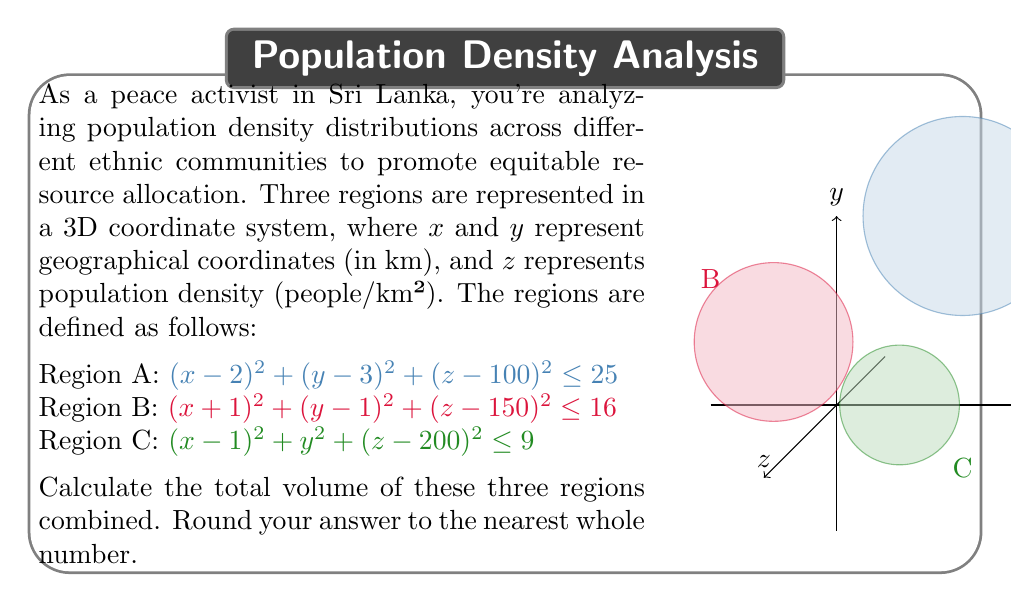Provide a solution to this math problem. Let's approach this step-by-step:

1) The given equations represent spheres in 3D space. The general equation for a sphere is $(x-h)^2 + (y-k)^2 + (z-l)^2 = r^2$, where $(h,k,l)$ is the center and $r$ is the radius.

2) For Region A:
   Center: (2, 3, 100)
   Radius: $\sqrt{25} = 5$

3) For Region B:
   Center: (-1, 1, 150)
   Radius: $\sqrt{16} = 4$

4) For Region C:
   Center: (1, 0, 200)
   Radius: $\sqrt{9} = 3$

5) The volume of a sphere is given by the formula $V = \frac{4}{3}\pi r^3$

6) Let's calculate the volume for each region:

   Region A: $V_A = \frac{4}{3}\pi 5^3 = \frac{500}{3}\pi$
   Region B: $V_B = \frac{4}{3}\pi 4^3 = \frac{256}{3}\pi$
   Region C: $V_C = \frac{4}{3}\pi 3^3 = 36\pi$

7) The total volume is the sum of these three volumes:

   $V_{total} = V_A + V_B + V_C = (\frac{500}{3} + \frac{256}{3} + 36)\pi$
              $= (\frac{500 + 256 + 108}{3})\pi$
              $= \frac{864}{3}\pi$
              $= 288\pi$

8) $288\pi \approx 904.78$

9) Rounding to the nearest whole number: 905

This total volume represents the combined geographical space and population density of the three ethnic communities, which is crucial for equitable resource allocation and reconciliation efforts.
Answer: 905 